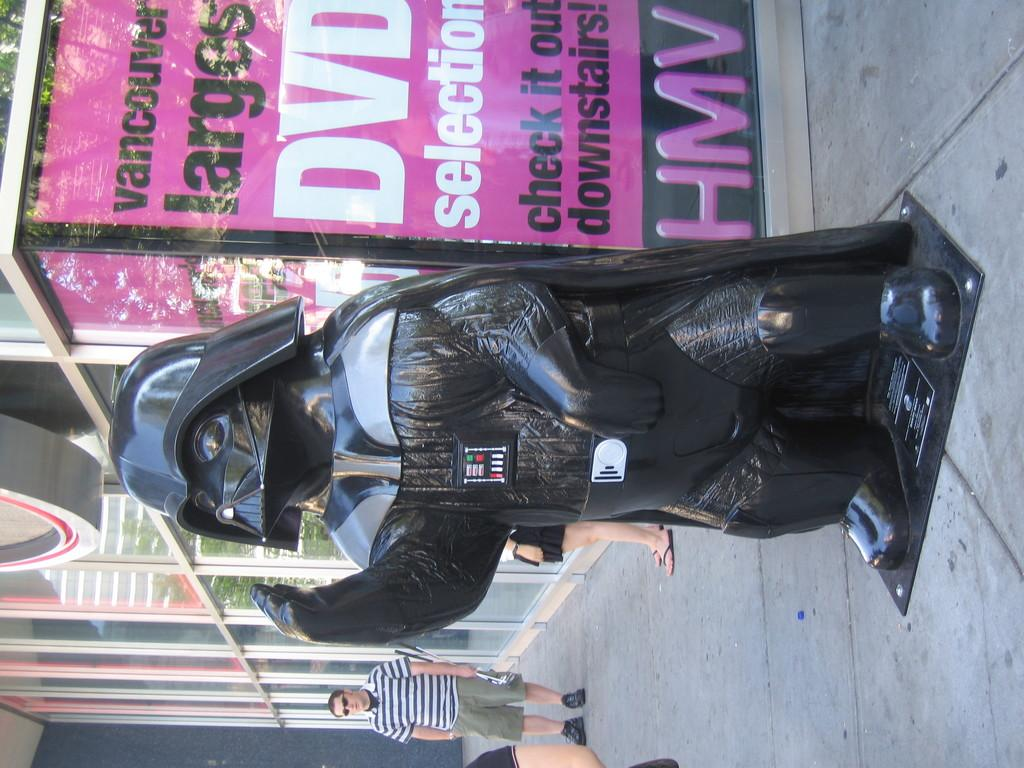What can be seen in the image besides people? There is a sculpture, a floor, a poster, and glass doors visible in the image. Can you describe the sculpture in the image? Unfortunately, the facts provided do not give a detailed description of the sculpture. What is the poster displaying in the image? The facts provided do not give information about the content of the poster. What type of doors are present in the image? The doors in the image are glass doors. How many cats are sitting on top of the appliance in the image? There is no appliance or cats present in the image. Is there a star visible in the image? There is no star visible in the image. 